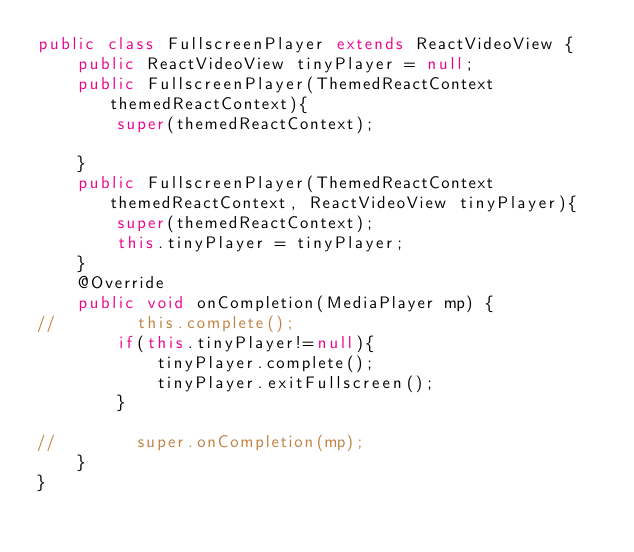<code> <loc_0><loc_0><loc_500><loc_500><_Java_>public class FullscreenPlayer extends ReactVideoView {
    public ReactVideoView tinyPlayer = null;
    public FullscreenPlayer(ThemedReactContext themedReactContext){
        super(themedReactContext);

    }
    public FullscreenPlayer(ThemedReactContext themedReactContext, ReactVideoView tinyPlayer){
        super(themedReactContext);
        this.tinyPlayer = tinyPlayer;
    }
    @Override
    public void onCompletion(MediaPlayer mp) {
//        this.complete();
        if(this.tinyPlayer!=null){
            tinyPlayer.complete();
            tinyPlayer.exitFullscreen();
        }

//        super.onCompletion(mp);
    }
}
</code> 